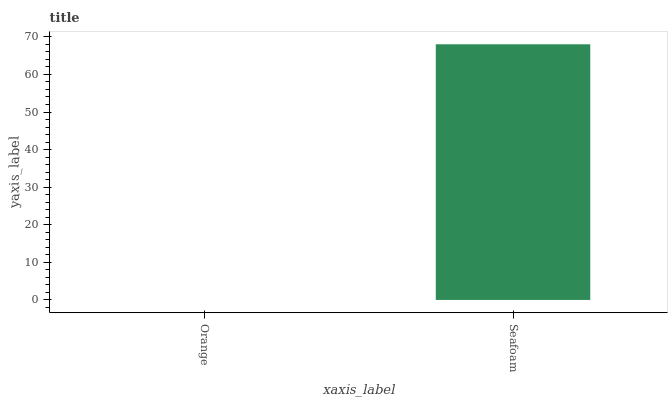Is Seafoam the minimum?
Answer yes or no. No. Is Seafoam greater than Orange?
Answer yes or no. Yes. Is Orange less than Seafoam?
Answer yes or no. Yes. Is Orange greater than Seafoam?
Answer yes or no. No. Is Seafoam less than Orange?
Answer yes or no. No. Is Seafoam the high median?
Answer yes or no. Yes. Is Orange the low median?
Answer yes or no. Yes. Is Orange the high median?
Answer yes or no. No. Is Seafoam the low median?
Answer yes or no. No. 